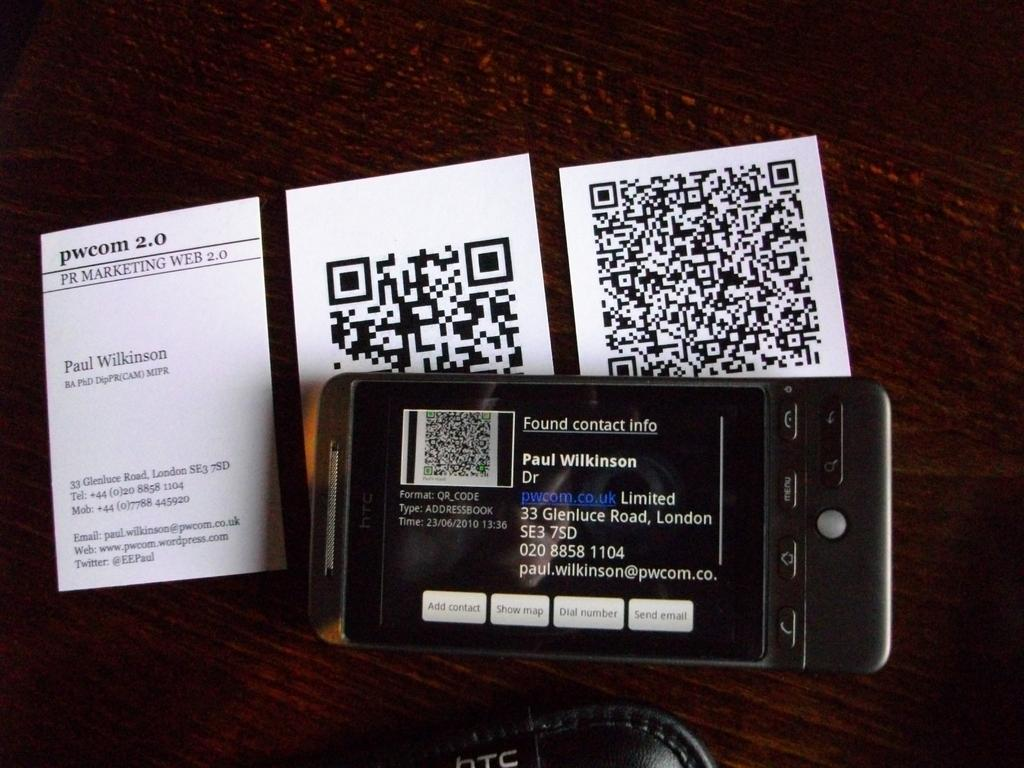<image>
Share a concise interpretation of the image provided. An electronic device has the owner's information on it. 